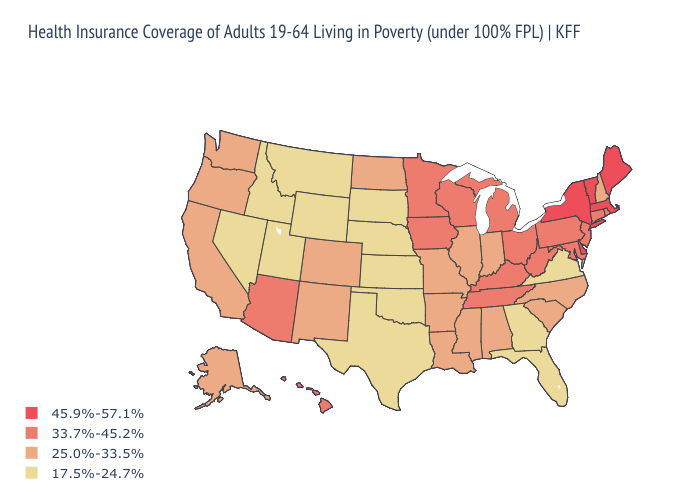What is the lowest value in the USA?
Quick response, please. 17.5%-24.7%. Among the states that border North Dakota , which have the lowest value?
Write a very short answer. Montana, South Dakota. Which states have the highest value in the USA?
Give a very brief answer. Delaware, Maine, Massachusetts, New York, Vermont. Name the states that have a value in the range 17.5%-24.7%?
Be succinct. Florida, Georgia, Idaho, Kansas, Montana, Nebraska, Nevada, Oklahoma, South Dakota, Texas, Utah, Virginia, Wyoming. Name the states that have a value in the range 45.9%-57.1%?
Answer briefly. Delaware, Maine, Massachusetts, New York, Vermont. Name the states that have a value in the range 17.5%-24.7%?
Short answer required. Florida, Georgia, Idaho, Kansas, Montana, Nebraska, Nevada, Oklahoma, South Dakota, Texas, Utah, Virginia, Wyoming. Name the states that have a value in the range 33.7%-45.2%?
Keep it brief. Arizona, Connecticut, Hawaii, Iowa, Kentucky, Maryland, Michigan, Minnesota, New Jersey, Ohio, Pennsylvania, Rhode Island, Tennessee, West Virginia, Wisconsin. What is the value of Texas?
Concise answer only. 17.5%-24.7%. Name the states that have a value in the range 17.5%-24.7%?
Give a very brief answer. Florida, Georgia, Idaho, Kansas, Montana, Nebraska, Nevada, Oklahoma, South Dakota, Texas, Utah, Virginia, Wyoming. Which states have the lowest value in the USA?
Keep it brief. Florida, Georgia, Idaho, Kansas, Montana, Nebraska, Nevada, Oklahoma, South Dakota, Texas, Utah, Virginia, Wyoming. What is the value of Montana?
Be succinct. 17.5%-24.7%. Among the states that border Arizona , which have the highest value?
Short answer required. California, Colorado, New Mexico. What is the lowest value in states that border Wisconsin?
Answer briefly. 25.0%-33.5%. What is the value of Illinois?
Short answer required. 25.0%-33.5%. Does Indiana have the highest value in the USA?
Answer briefly. No. 